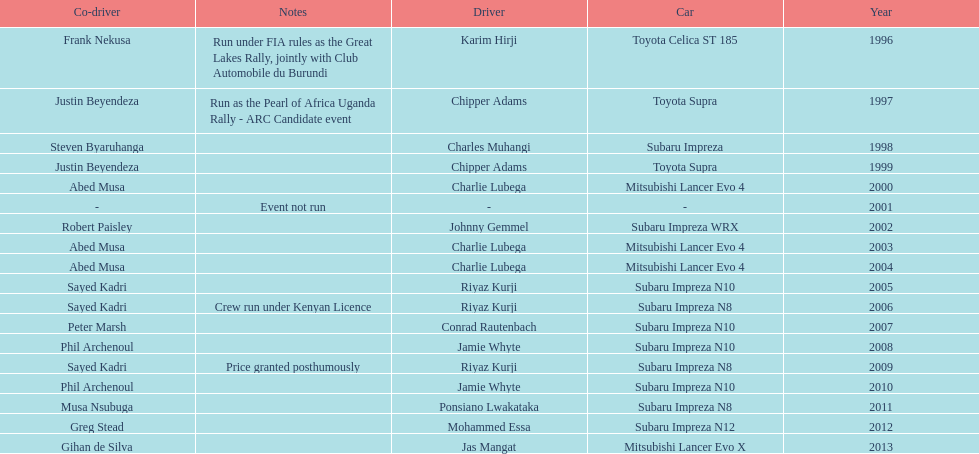How many times was charlie lubega a driver? 3. 